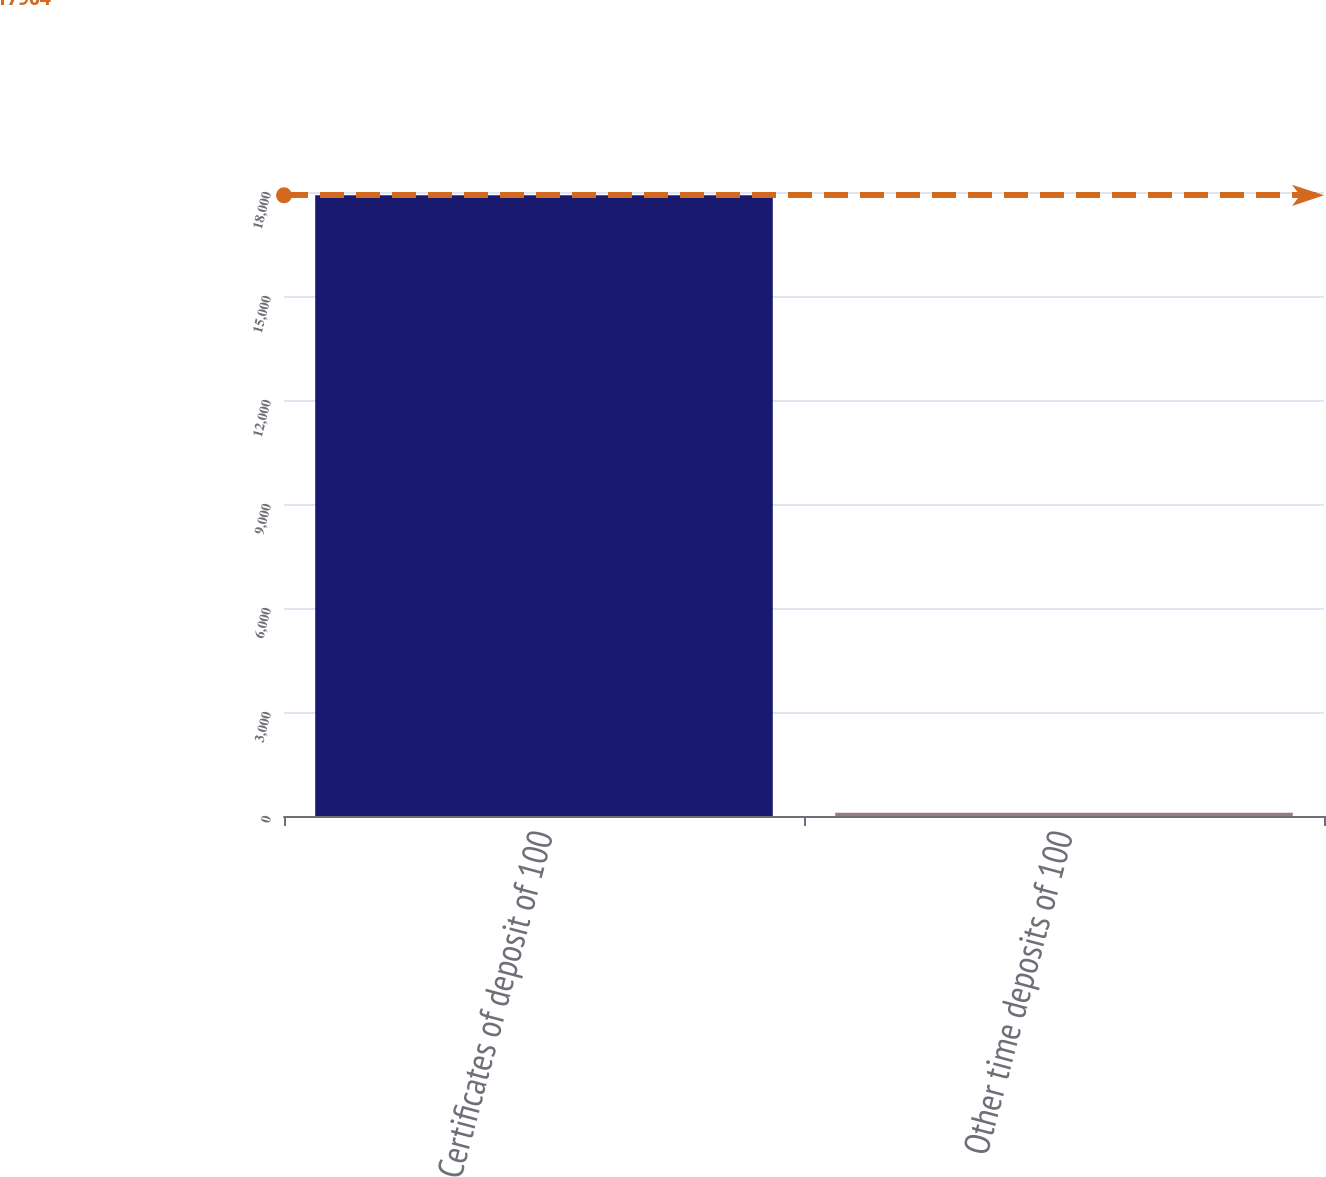<chart> <loc_0><loc_0><loc_500><loc_500><bar_chart><fcel>Certificates of deposit of 100<fcel>Other time deposits of 100<nl><fcel>17904<fcel>96<nl></chart> 